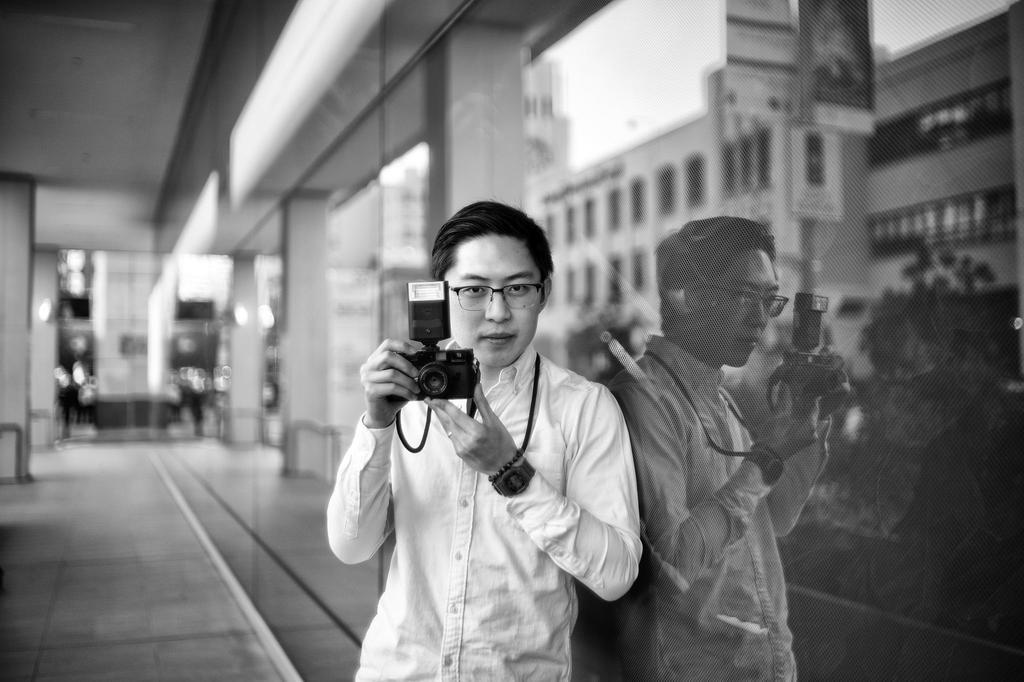Who is present in the image? There is a man in the image. What is the man doing in the image? The man is standing in the image. What is the man holding in his hands? The man is holding a camera in his hands. What can be seen in the background of the image? There is a building and a plant in the image. What type of dinosaur can be seen in the image? There are no dinosaurs present in the image. What shape is the plant in the image? The provided facts do not mention the shape of the plant, so it cannot be determined from the image. 